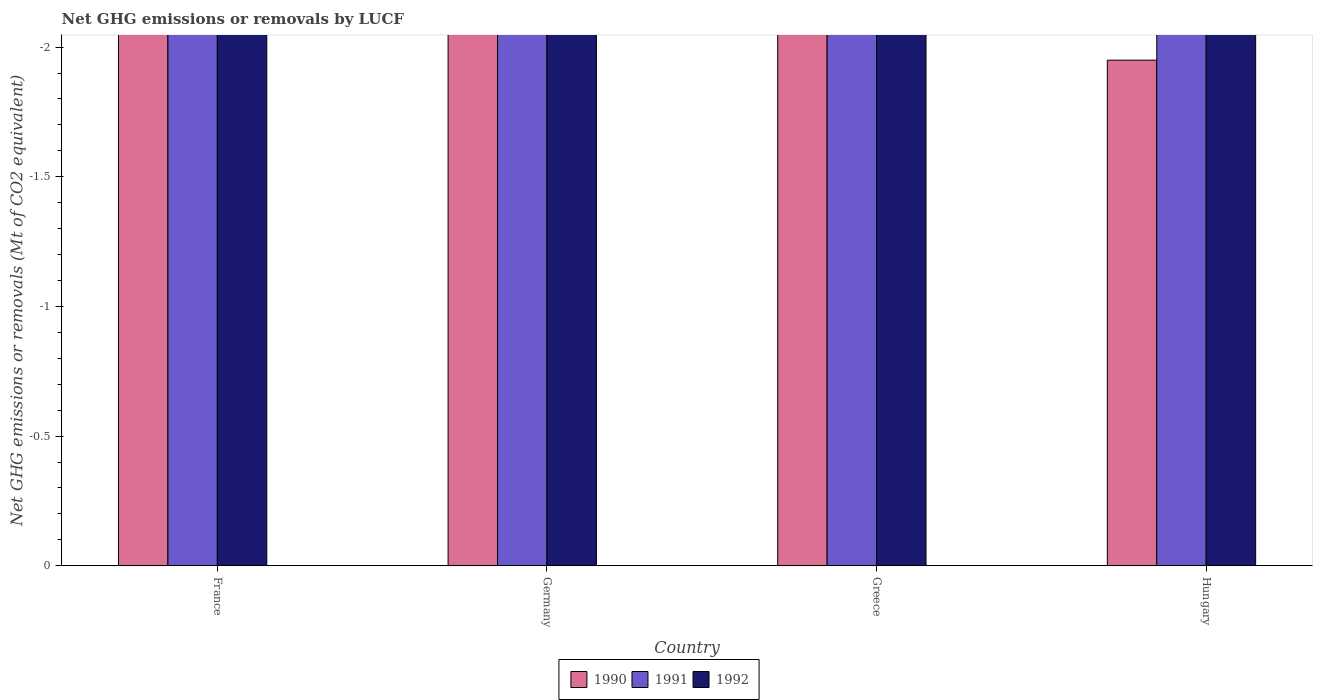Are the number of bars on each tick of the X-axis equal?
Ensure brevity in your answer.  Yes. How many bars are there on the 3rd tick from the left?
Your answer should be compact. 0. How many bars are there on the 1st tick from the right?
Your answer should be very brief. 0. What is the label of the 2nd group of bars from the left?
Offer a terse response. Germany. In how many cases, is the number of bars for a given country not equal to the number of legend labels?
Your response must be concise. 4. What is the difference between the net GHG emissions or removals by LUCF in 1992 in Hungary and the net GHG emissions or removals by LUCF in 1990 in Germany?
Keep it short and to the point. 0. Is it the case that in every country, the sum of the net GHG emissions or removals by LUCF in 1990 and net GHG emissions or removals by LUCF in 1991 is greater than the net GHG emissions or removals by LUCF in 1992?
Give a very brief answer. No. How many countries are there in the graph?
Provide a short and direct response. 4. Are the values on the major ticks of Y-axis written in scientific E-notation?
Keep it short and to the point. No. Does the graph contain any zero values?
Offer a very short reply. Yes. How are the legend labels stacked?
Your response must be concise. Horizontal. What is the title of the graph?
Provide a short and direct response. Net GHG emissions or removals by LUCF. What is the label or title of the Y-axis?
Ensure brevity in your answer.  Net GHG emissions or removals (Mt of CO2 equivalent). What is the Net GHG emissions or removals (Mt of CO2 equivalent) of 1992 in France?
Keep it short and to the point. 0. What is the Net GHG emissions or removals (Mt of CO2 equivalent) of 1991 in Germany?
Your answer should be compact. 0. What is the Net GHG emissions or removals (Mt of CO2 equivalent) of 1992 in Germany?
Ensure brevity in your answer.  0. What is the Net GHG emissions or removals (Mt of CO2 equivalent) in 1990 in Greece?
Your answer should be very brief. 0. What is the Net GHG emissions or removals (Mt of CO2 equivalent) of 1992 in Greece?
Ensure brevity in your answer.  0. What is the total Net GHG emissions or removals (Mt of CO2 equivalent) of 1992 in the graph?
Keep it short and to the point. 0. What is the average Net GHG emissions or removals (Mt of CO2 equivalent) of 1990 per country?
Give a very brief answer. 0. 